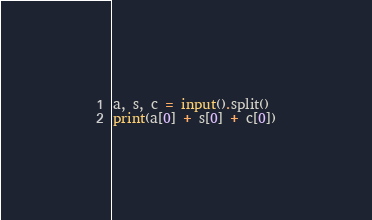<code> <loc_0><loc_0><loc_500><loc_500><_Python_>a, s, c = input().split()
print(a[0] + s[0] + c[0])</code> 